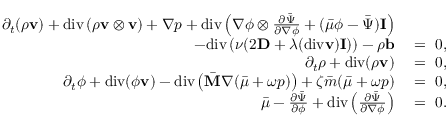<formula> <loc_0><loc_0><loc_500><loc_500>\begin{array} { r l } { \partial _ { t } ( \rho v ) + d i v \left ( \rho v \otimes v \right ) + \nabla p + d i v \left ( \nabla \phi \otimes \frac { \partial \bar { \Psi } } { \partial \nabla \phi } + ( \bar { \mu } \phi - \bar { \Psi } ) I \right ) } \\ { - d i v \left ( \nu ( 2 D + \lambda ( d i v v ) I ) \right ) - \rho b } & = 0 , } \\ { \partial _ { t } \rho + d i v ( \rho v ) } & = 0 , } \\ { \partial _ { t } \phi + d i v ( \phi v ) - d i v \left ( \bar { M } \nabla ( \bar { \mu } + \omega p ) \right ) + \zeta \bar { m } ( \bar { \mu } + \omega p ) } & = 0 , } \\ { \bar { \mu } - \frac { \partial \bar { \Psi } } { \partial \phi } + d i v \left ( \frac { \partial \bar { \Psi } } { \partial \nabla \phi } \right ) } & = 0 . } \end{array}</formula> 